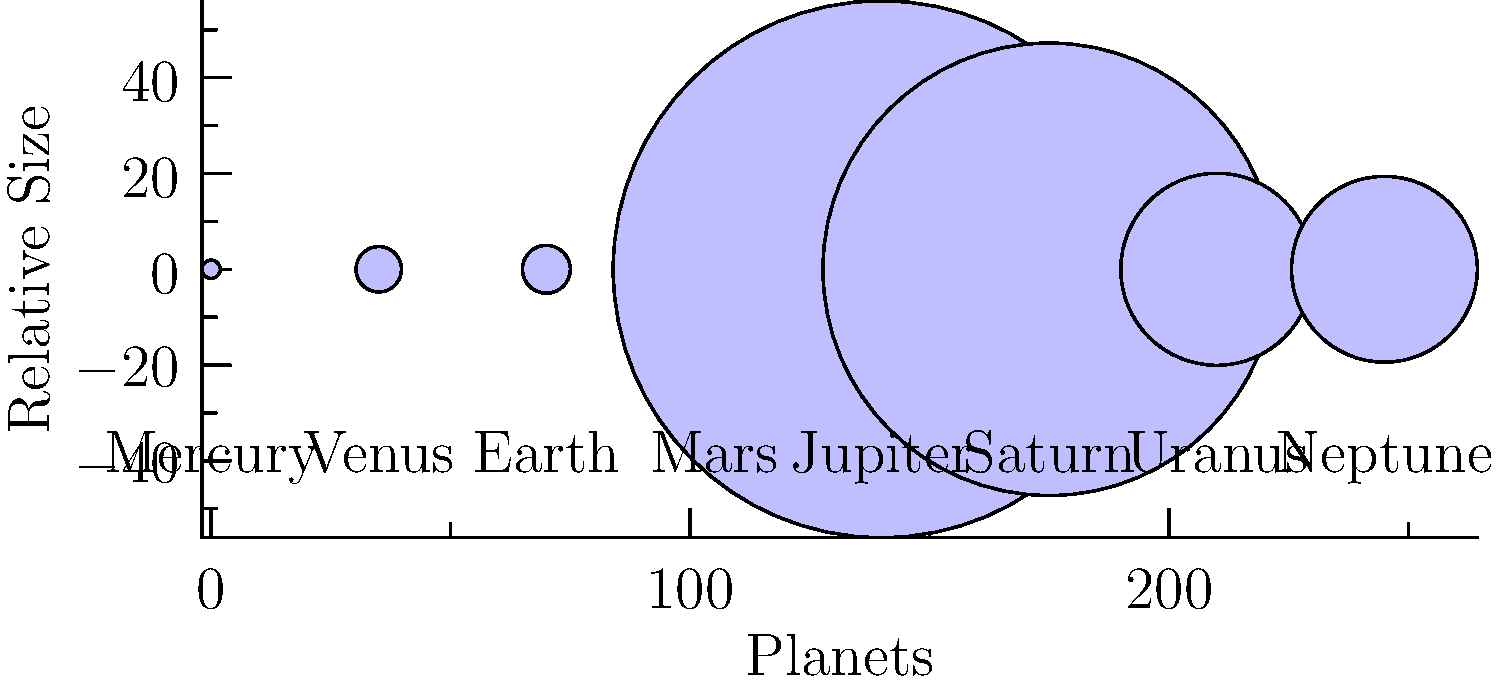As a proud parent of a Weston High School student, you're helping your child study for an astronomy test. Looking at the chart of planets in our solar system, which classification best describes the first four planets (Mercury to Mars) compared to the last four (Jupiter to Neptune)? To answer this question, let's analyze the chart step-by-step:

1. Observe the relative sizes of the planets:
   - Mercury, Venus, Earth, and Mars are significantly smaller.
   - Jupiter, Saturn, Uranus, and Neptune are much larger.

2. Recall the classification of planets:
   - Terrestrial (rocky) planets: Smaller, solid surfaces, closer to the Sun.
   - Gas giants: Larger, mostly composed of gases, farther from the Sun.

3. Compare the two groups:
   - Mercury to Mars: Small, rocky planets with solid surfaces.
   - Jupiter to Neptune: Large, gaseous planets.

4. Match the characteristics:
   - The first four planets fit the description of terrestrial planets.
   - The last four planets fit the description of gas giants.

Therefore, the best classification for the first four planets (Mercury to Mars) is terrestrial planets, while the last four (Jupiter to Neptune) are gas giants.
Answer: Terrestrial planets 